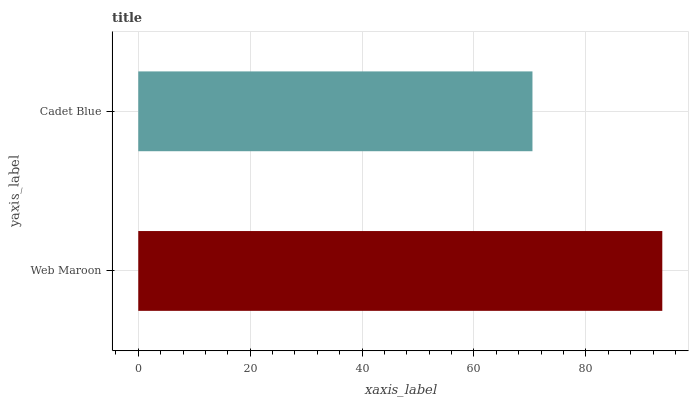Is Cadet Blue the minimum?
Answer yes or no. Yes. Is Web Maroon the maximum?
Answer yes or no. Yes. Is Cadet Blue the maximum?
Answer yes or no. No. Is Web Maroon greater than Cadet Blue?
Answer yes or no. Yes. Is Cadet Blue less than Web Maroon?
Answer yes or no. Yes. Is Cadet Blue greater than Web Maroon?
Answer yes or no. No. Is Web Maroon less than Cadet Blue?
Answer yes or no. No. Is Web Maroon the high median?
Answer yes or no. Yes. Is Cadet Blue the low median?
Answer yes or no. Yes. Is Cadet Blue the high median?
Answer yes or no. No. Is Web Maroon the low median?
Answer yes or no. No. 